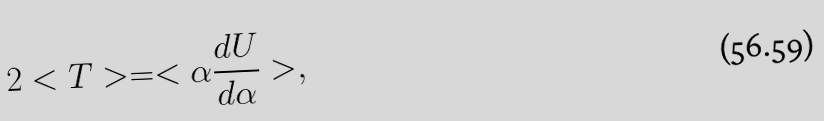Convert formula to latex. <formula><loc_0><loc_0><loc_500><loc_500>2 < T > = < \alpha \frac { d U } { d \alpha } > ,</formula> 